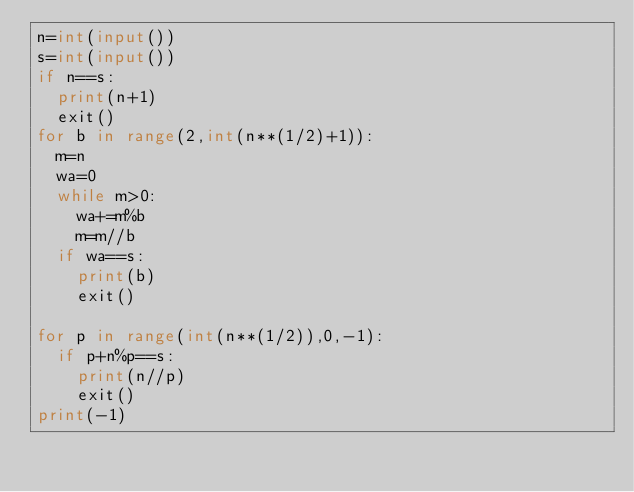Convert code to text. <code><loc_0><loc_0><loc_500><loc_500><_Python_>n=int(input())
s=int(input())
if n==s:
  print(n+1)
  exit()
for b in range(2,int(n**(1/2)+1)):
  m=n
  wa=0
  while m>0:
    wa+=m%b
    m=m//b
  if wa==s:
    print(b)
    exit()

for p in range(int(n**(1/2)),0,-1):
  if p+n%p==s:
    print(n//p)
    exit()
print(-1)   </code> 